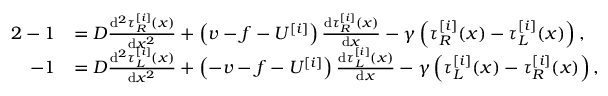Convert formula to latex. <formula><loc_0><loc_0><loc_500><loc_500>\begin{array} { r l } { { 2 } - 1 } & { = D \frac { d ^ { 2 } \tau _ { R } ^ { [ i ] } ( x ) } { d x ^ { 2 } } + \left ( v - f - U ^ { [ i ] } \right ) \frac { d \tau _ { R } ^ { [ i ] } ( x ) } { d x } - \gamma \left ( \tau _ { R } ^ { [ i ] } ( x ) - \tau _ { L } ^ { [ i ] } ( x ) \right ) , } \\ { - 1 } & { = D \frac { d ^ { 2 } \tau _ { L } ^ { [ i ] } ( x ) } { d x ^ { 2 } } + \left ( - v - f - U ^ { [ i ] } \right ) \frac { d \tau _ { L } ^ { [ i ] } ( x ) } { d x } - \gamma \left ( \tau _ { L } ^ { [ i ] } ( x ) - \tau _ { R } ^ { [ i ] } ( x ) \right ) , } \end{array}</formula> 